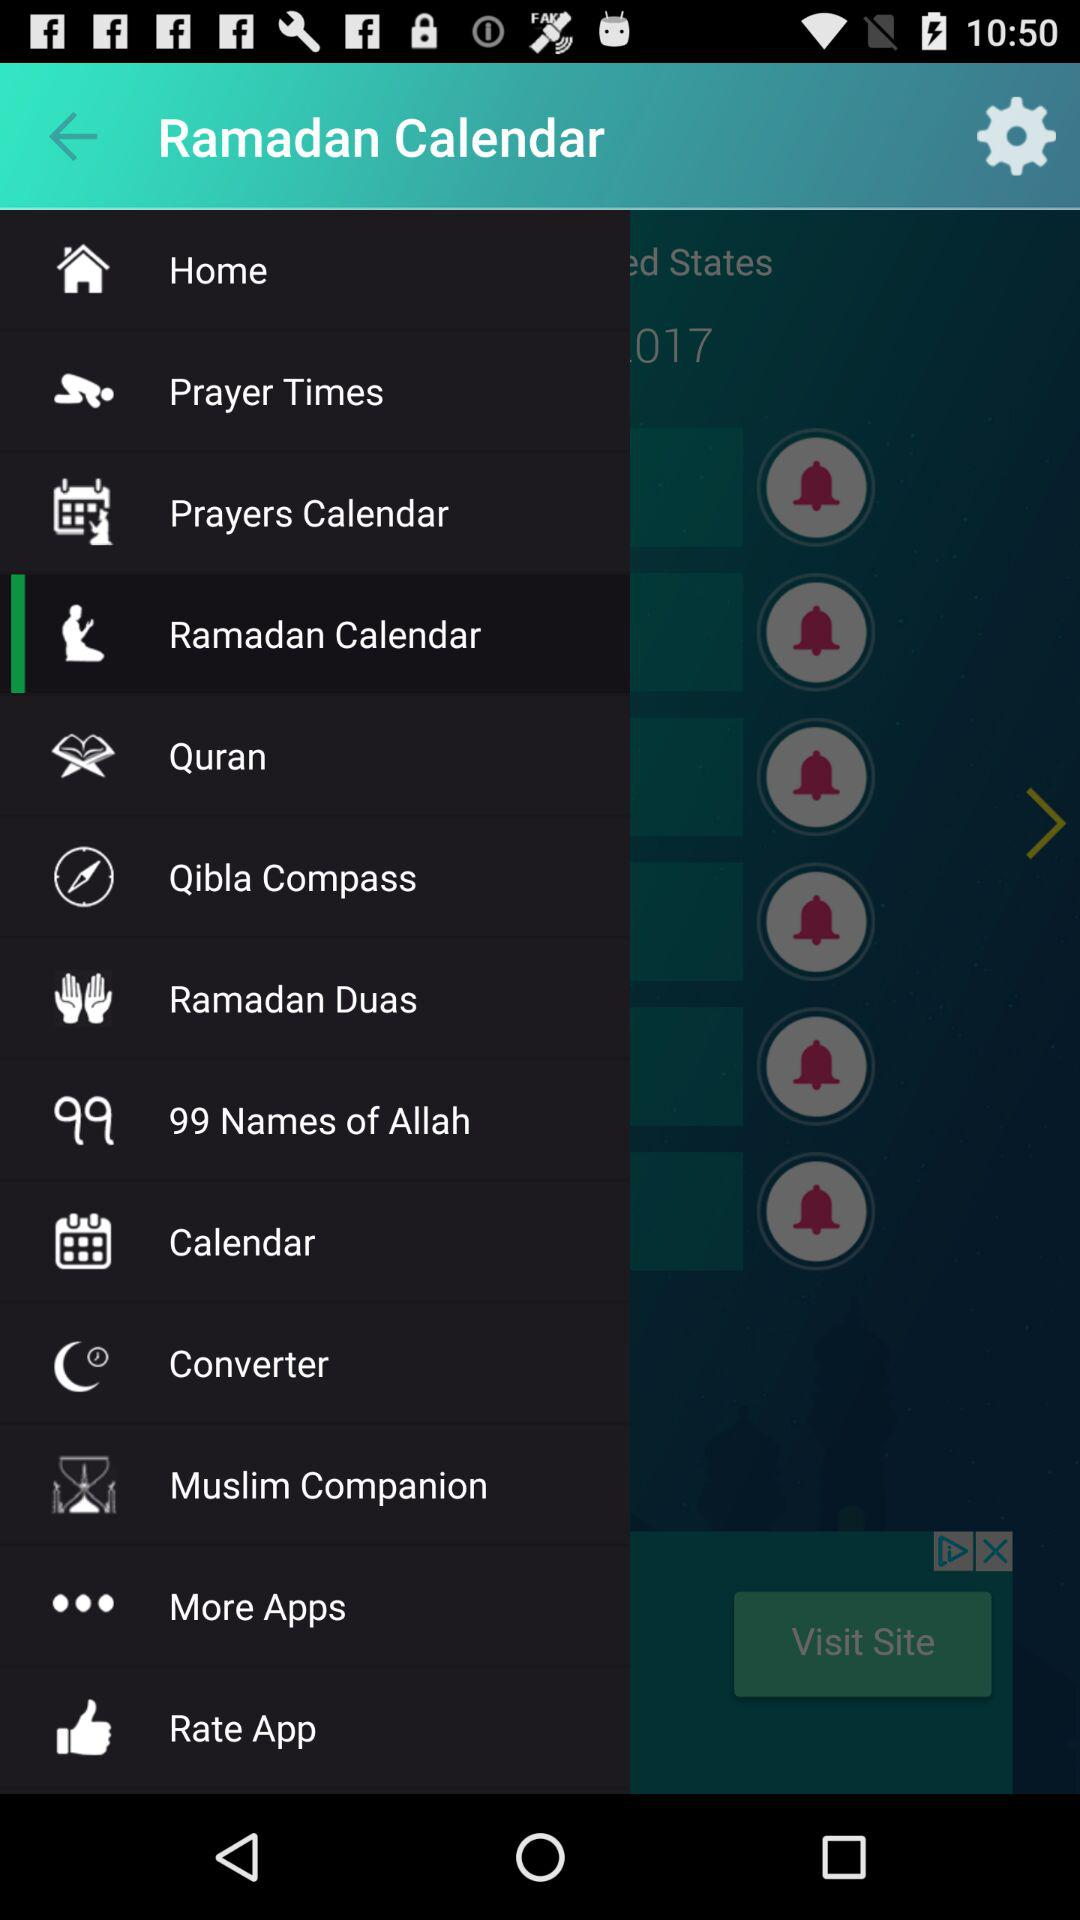What is the name of the application? The name of the application is "Ramadan calendar". 